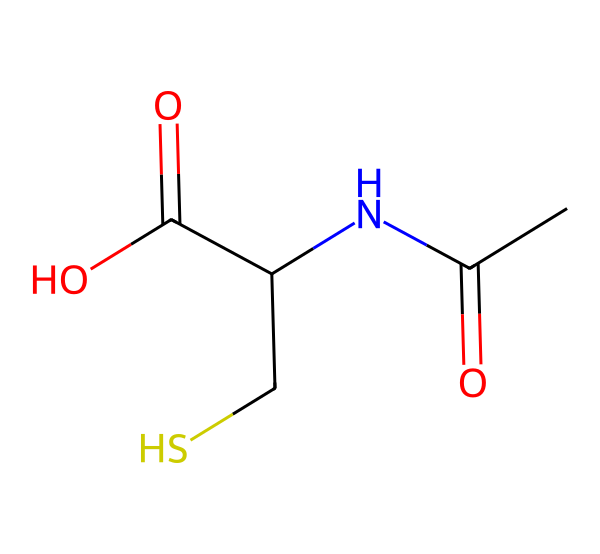What is the main functional group present in N-acetylcysteine? The main functional group in N-acetylcysteine is the amine group (-NH). This can be identified by looking at the nitrogen atom connected to a carbon atom and the hydrogen atoms.
Answer: amine How many carbon atoms are present in N-acetylcysteine? By examining the SMILES representation, there are five carbon atoms indicated by 'C' in the structure.
Answer: five What type of bond is found between the carbon and the nitrogen in N-acetylcysteine? The bond between the carbon and nitrogen is a single bond, as seen by the absence of any symbols that indicate double or triple bonds between them in the SMILES.
Answer: single bond Which element's presence in N-acetylcysteine contributes to its classification as a sulfur compound? The presence of sulfur (indicated by 'S' in the SMILES) classifies N-acetylcysteine as a sulfur compound.
Answer: sulfur What role does the acetyl group play in the structure of N-acetylcysteine? The acetyl group (indicated by ‘CC(=O)’) contributes to the molecular identity by providing the acetylation, which enhances solubility and bioavailability in tissues.
Answer: enhances solubility How many total nitrogen and sulfur atoms are in the N-acetylcysteine molecule? There is one nitrogen atom (N) and one sulfur atom (S) based on the SMILES representation.
Answer: one nitrogen and one sulfur 